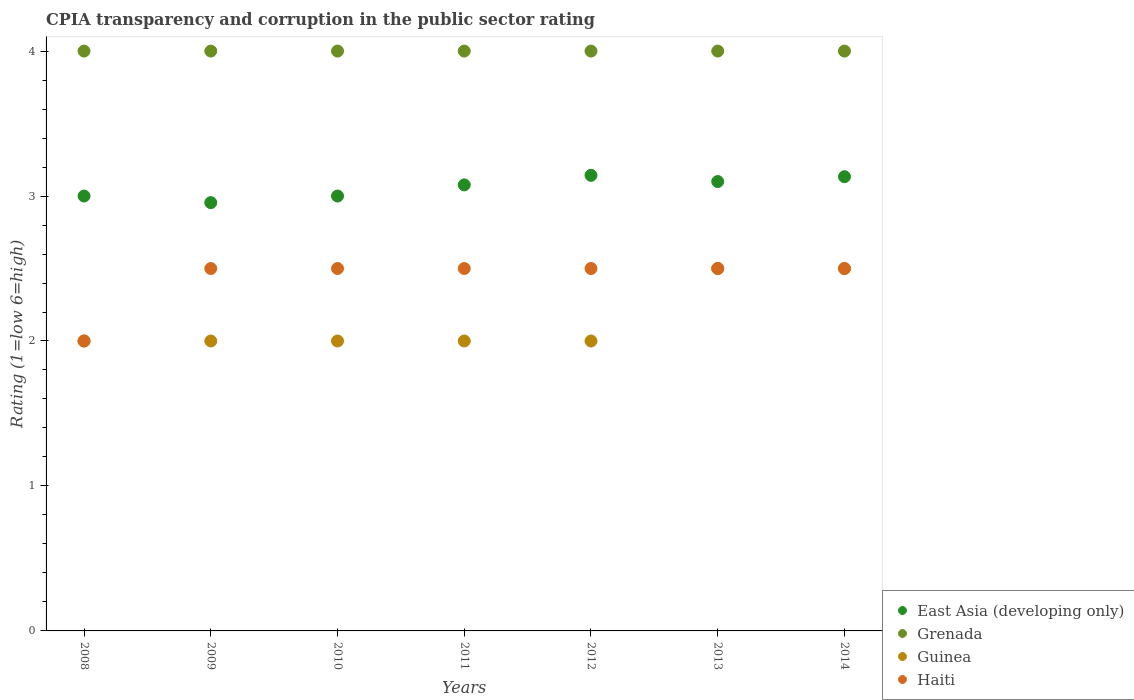Is the number of dotlines equal to the number of legend labels?
Your answer should be compact. Yes. What is the CPIA rating in East Asia (developing only) in 2010?
Your answer should be compact. 3. Across all years, what is the minimum CPIA rating in Grenada?
Provide a succinct answer. 4. In which year was the CPIA rating in Haiti minimum?
Your answer should be compact. 2008. What is the total CPIA rating in Grenada in the graph?
Make the answer very short. 28. What is the difference between the CPIA rating in Haiti in 2010 and that in 2012?
Make the answer very short. 0. What is the average CPIA rating in Haiti per year?
Offer a very short reply. 2.43. What is the ratio of the CPIA rating in Haiti in 2010 to that in 2011?
Ensure brevity in your answer.  1. Is it the case that in every year, the sum of the CPIA rating in East Asia (developing only) and CPIA rating in Haiti  is greater than the CPIA rating in Grenada?
Offer a very short reply. Yes. Is the CPIA rating in Guinea strictly greater than the CPIA rating in Grenada over the years?
Your response must be concise. No. How many years are there in the graph?
Give a very brief answer. 7. Are the values on the major ticks of Y-axis written in scientific E-notation?
Offer a very short reply. No. How many legend labels are there?
Make the answer very short. 4. What is the title of the graph?
Your answer should be compact. CPIA transparency and corruption in the public sector rating. What is the label or title of the X-axis?
Ensure brevity in your answer.  Years. What is the Rating (1=low 6=high) in Grenada in 2008?
Your answer should be very brief. 4. What is the Rating (1=low 6=high) in East Asia (developing only) in 2009?
Offer a terse response. 2.95. What is the Rating (1=low 6=high) of Guinea in 2009?
Make the answer very short. 2. What is the Rating (1=low 6=high) in Grenada in 2010?
Offer a terse response. 4. What is the Rating (1=low 6=high) of Guinea in 2010?
Give a very brief answer. 2. What is the Rating (1=low 6=high) in East Asia (developing only) in 2011?
Your answer should be very brief. 3.08. What is the Rating (1=low 6=high) of Grenada in 2011?
Offer a terse response. 4. What is the Rating (1=low 6=high) of Guinea in 2011?
Offer a terse response. 2. What is the Rating (1=low 6=high) in East Asia (developing only) in 2012?
Your answer should be very brief. 3.14. What is the Rating (1=low 6=high) of Guinea in 2012?
Offer a terse response. 2. What is the Rating (1=low 6=high) of Haiti in 2012?
Offer a terse response. 2.5. What is the Rating (1=low 6=high) in Haiti in 2013?
Make the answer very short. 2.5. What is the Rating (1=low 6=high) of East Asia (developing only) in 2014?
Make the answer very short. 3.13. What is the Rating (1=low 6=high) of Grenada in 2014?
Provide a short and direct response. 4. What is the Rating (1=low 6=high) in Guinea in 2014?
Make the answer very short. 2.5. Across all years, what is the maximum Rating (1=low 6=high) in East Asia (developing only)?
Offer a very short reply. 3.14. Across all years, what is the maximum Rating (1=low 6=high) in Guinea?
Your answer should be compact. 2.5. Across all years, what is the maximum Rating (1=low 6=high) in Haiti?
Your answer should be very brief. 2.5. Across all years, what is the minimum Rating (1=low 6=high) in East Asia (developing only)?
Your answer should be very brief. 2.95. Across all years, what is the minimum Rating (1=low 6=high) of Grenada?
Provide a succinct answer. 4. Across all years, what is the minimum Rating (1=low 6=high) of Haiti?
Your response must be concise. 2. What is the total Rating (1=low 6=high) of East Asia (developing only) in the graph?
Provide a succinct answer. 21.41. What is the difference between the Rating (1=low 6=high) of East Asia (developing only) in 2008 and that in 2009?
Your answer should be compact. 0.05. What is the difference between the Rating (1=low 6=high) in Grenada in 2008 and that in 2009?
Your response must be concise. 0. What is the difference between the Rating (1=low 6=high) of Guinea in 2008 and that in 2009?
Keep it short and to the point. 0. What is the difference between the Rating (1=low 6=high) in East Asia (developing only) in 2008 and that in 2011?
Make the answer very short. -0.08. What is the difference between the Rating (1=low 6=high) in Haiti in 2008 and that in 2011?
Provide a succinct answer. -0.5. What is the difference between the Rating (1=low 6=high) in East Asia (developing only) in 2008 and that in 2012?
Your answer should be very brief. -0.14. What is the difference between the Rating (1=low 6=high) in Haiti in 2008 and that in 2012?
Provide a short and direct response. -0.5. What is the difference between the Rating (1=low 6=high) of East Asia (developing only) in 2008 and that in 2013?
Your response must be concise. -0.1. What is the difference between the Rating (1=low 6=high) in Grenada in 2008 and that in 2013?
Provide a succinct answer. 0. What is the difference between the Rating (1=low 6=high) in East Asia (developing only) in 2008 and that in 2014?
Provide a short and direct response. -0.13. What is the difference between the Rating (1=low 6=high) in Guinea in 2008 and that in 2014?
Keep it short and to the point. -0.5. What is the difference between the Rating (1=low 6=high) in Haiti in 2008 and that in 2014?
Make the answer very short. -0.5. What is the difference between the Rating (1=low 6=high) in East Asia (developing only) in 2009 and that in 2010?
Make the answer very short. -0.05. What is the difference between the Rating (1=low 6=high) of Haiti in 2009 and that in 2010?
Ensure brevity in your answer.  0. What is the difference between the Rating (1=low 6=high) of East Asia (developing only) in 2009 and that in 2011?
Your response must be concise. -0.12. What is the difference between the Rating (1=low 6=high) in Guinea in 2009 and that in 2011?
Offer a terse response. 0. What is the difference between the Rating (1=low 6=high) in Haiti in 2009 and that in 2011?
Ensure brevity in your answer.  0. What is the difference between the Rating (1=low 6=high) of East Asia (developing only) in 2009 and that in 2012?
Make the answer very short. -0.19. What is the difference between the Rating (1=low 6=high) of Grenada in 2009 and that in 2012?
Give a very brief answer. 0. What is the difference between the Rating (1=low 6=high) in Haiti in 2009 and that in 2012?
Your answer should be compact. 0. What is the difference between the Rating (1=low 6=high) of East Asia (developing only) in 2009 and that in 2013?
Keep it short and to the point. -0.15. What is the difference between the Rating (1=low 6=high) in Grenada in 2009 and that in 2013?
Your response must be concise. 0. What is the difference between the Rating (1=low 6=high) of Guinea in 2009 and that in 2013?
Make the answer very short. -0.5. What is the difference between the Rating (1=low 6=high) in East Asia (developing only) in 2009 and that in 2014?
Offer a very short reply. -0.18. What is the difference between the Rating (1=low 6=high) in Grenada in 2009 and that in 2014?
Make the answer very short. 0. What is the difference between the Rating (1=low 6=high) in Guinea in 2009 and that in 2014?
Your response must be concise. -0.5. What is the difference between the Rating (1=low 6=high) in East Asia (developing only) in 2010 and that in 2011?
Ensure brevity in your answer.  -0.08. What is the difference between the Rating (1=low 6=high) in Grenada in 2010 and that in 2011?
Your answer should be very brief. 0. What is the difference between the Rating (1=low 6=high) in Haiti in 2010 and that in 2011?
Provide a succinct answer. 0. What is the difference between the Rating (1=low 6=high) of East Asia (developing only) in 2010 and that in 2012?
Offer a terse response. -0.14. What is the difference between the Rating (1=low 6=high) of Haiti in 2010 and that in 2012?
Provide a succinct answer. 0. What is the difference between the Rating (1=low 6=high) in Guinea in 2010 and that in 2013?
Provide a succinct answer. -0.5. What is the difference between the Rating (1=low 6=high) in Haiti in 2010 and that in 2013?
Your response must be concise. 0. What is the difference between the Rating (1=low 6=high) in East Asia (developing only) in 2010 and that in 2014?
Ensure brevity in your answer.  -0.13. What is the difference between the Rating (1=low 6=high) of Haiti in 2010 and that in 2014?
Your answer should be compact. 0. What is the difference between the Rating (1=low 6=high) in East Asia (developing only) in 2011 and that in 2012?
Ensure brevity in your answer.  -0.07. What is the difference between the Rating (1=low 6=high) of Guinea in 2011 and that in 2012?
Give a very brief answer. 0. What is the difference between the Rating (1=low 6=high) in East Asia (developing only) in 2011 and that in 2013?
Your response must be concise. -0.02. What is the difference between the Rating (1=low 6=high) in Grenada in 2011 and that in 2013?
Your answer should be very brief. 0. What is the difference between the Rating (1=low 6=high) in Haiti in 2011 and that in 2013?
Ensure brevity in your answer.  0. What is the difference between the Rating (1=low 6=high) in East Asia (developing only) in 2011 and that in 2014?
Offer a terse response. -0.06. What is the difference between the Rating (1=low 6=high) in Guinea in 2011 and that in 2014?
Give a very brief answer. -0.5. What is the difference between the Rating (1=low 6=high) in East Asia (developing only) in 2012 and that in 2013?
Your answer should be compact. 0.04. What is the difference between the Rating (1=low 6=high) in Grenada in 2012 and that in 2013?
Your answer should be compact. 0. What is the difference between the Rating (1=low 6=high) in East Asia (developing only) in 2012 and that in 2014?
Offer a very short reply. 0.01. What is the difference between the Rating (1=low 6=high) of Grenada in 2012 and that in 2014?
Offer a terse response. 0. What is the difference between the Rating (1=low 6=high) in East Asia (developing only) in 2013 and that in 2014?
Give a very brief answer. -0.03. What is the difference between the Rating (1=low 6=high) of East Asia (developing only) in 2008 and the Rating (1=low 6=high) of Haiti in 2009?
Provide a succinct answer. 0.5. What is the difference between the Rating (1=low 6=high) in Grenada in 2008 and the Rating (1=low 6=high) in Haiti in 2009?
Offer a very short reply. 1.5. What is the difference between the Rating (1=low 6=high) of Guinea in 2008 and the Rating (1=low 6=high) of Haiti in 2009?
Make the answer very short. -0.5. What is the difference between the Rating (1=low 6=high) in East Asia (developing only) in 2008 and the Rating (1=low 6=high) in Haiti in 2010?
Your response must be concise. 0.5. What is the difference between the Rating (1=low 6=high) of Grenada in 2008 and the Rating (1=low 6=high) of Guinea in 2010?
Make the answer very short. 2. What is the difference between the Rating (1=low 6=high) in Grenada in 2008 and the Rating (1=low 6=high) in Haiti in 2010?
Ensure brevity in your answer.  1.5. What is the difference between the Rating (1=low 6=high) in Grenada in 2008 and the Rating (1=low 6=high) in Guinea in 2011?
Make the answer very short. 2. What is the difference between the Rating (1=low 6=high) of Guinea in 2008 and the Rating (1=low 6=high) of Haiti in 2011?
Your answer should be compact. -0.5. What is the difference between the Rating (1=low 6=high) of Guinea in 2008 and the Rating (1=low 6=high) of Haiti in 2012?
Offer a very short reply. -0.5. What is the difference between the Rating (1=low 6=high) of East Asia (developing only) in 2008 and the Rating (1=low 6=high) of Grenada in 2013?
Give a very brief answer. -1. What is the difference between the Rating (1=low 6=high) in East Asia (developing only) in 2008 and the Rating (1=low 6=high) in Guinea in 2013?
Provide a succinct answer. 0.5. What is the difference between the Rating (1=low 6=high) of Guinea in 2008 and the Rating (1=low 6=high) of Haiti in 2013?
Provide a short and direct response. -0.5. What is the difference between the Rating (1=low 6=high) of East Asia (developing only) in 2008 and the Rating (1=low 6=high) of Grenada in 2014?
Your answer should be compact. -1. What is the difference between the Rating (1=low 6=high) of East Asia (developing only) in 2008 and the Rating (1=low 6=high) of Guinea in 2014?
Offer a terse response. 0.5. What is the difference between the Rating (1=low 6=high) of East Asia (developing only) in 2008 and the Rating (1=low 6=high) of Haiti in 2014?
Give a very brief answer. 0.5. What is the difference between the Rating (1=low 6=high) of East Asia (developing only) in 2009 and the Rating (1=low 6=high) of Grenada in 2010?
Your response must be concise. -1.05. What is the difference between the Rating (1=low 6=high) of East Asia (developing only) in 2009 and the Rating (1=low 6=high) of Guinea in 2010?
Keep it short and to the point. 0.95. What is the difference between the Rating (1=low 6=high) in East Asia (developing only) in 2009 and the Rating (1=low 6=high) in Haiti in 2010?
Your answer should be very brief. 0.45. What is the difference between the Rating (1=low 6=high) of Grenada in 2009 and the Rating (1=low 6=high) of Guinea in 2010?
Give a very brief answer. 2. What is the difference between the Rating (1=low 6=high) in Grenada in 2009 and the Rating (1=low 6=high) in Haiti in 2010?
Keep it short and to the point. 1.5. What is the difference between the Rating (1=low 6=high) in Guinea in 2009 and the Rating (1=low 6=high) in Haiti in 2010?
Offer a terse response. -0.5. What is the difference between the Rating (1=low 6=high) in East Asia (developing only) in 2009 and the Rating (1=low 6=high) in Grenada in 2011?
Provide a short and direct response. -1.05. What is the difference between the Rating (1=low 6=high) of East Asia (developing only) in 2009 and the Rating (1=low 6=high) of Guinea in 2011?
Provide a succinct answer. 0.95. What is the difference between the Rating (1=low 6=high) in East Asia (developing only) in 2009 and the Rating (1=low 6=high) in Haiti in 2011?
Your answer should be compact. 0.45. What is the difference between the Rating (1=low 6=high) of Guinea in 2009 and the Rating (1=low 6=high) of Haiti in 2011?
Give a very brief answer. -0.5. What is the difference between the Rating (1=low 6=high) in East Asia (developing only) in 2009 and the Rating (1=low 6=high) in Grenada in 2012?
Make the answer very short. -1.05. What is the difference between the Rating (1=low 6=high) in East Asia (developing only) in 2009 and the Rating (1=low 6=high) in Guinea in 2012?
Your response must be concise. 0.95. What is the difference between the Rating (1=low 6=high) in East Asia (developing only) in 2009 and the Rating (1=low 6=high) in Haiti in 2012?
Your answer should be compact. 0.45. What is the difference between the Rating (1=low 6=high) in Grenada in 2009 and the Rating (1=low 6=high) in Guinea in 2012?
Offer a very short reply. 2. What is the difference between the Rating (1=low 6=high) of Grenada in 2009 and the Rating (1=low 6=high) of Haiti in 2012?
Offer a terse response. 1.5. What is the difference between the Rating (1=low 6=high) of Guinea in 2009 and the Rating (1=low 6=high) of Haiti in 2012?
Your answer should be very brief. -0.5. What is the difference between the Rating (1=low 6=high) in East Asia (developing only) in 2009 and the Rating (1=low 6=high) in Grenada in 2013?
Keep it short and to the point. -1.05. What is the difference between the Rating (1=low 6=high) of East Asia (developing only) in 2009 and the Rating (1=low 6=high) of Guinea in 2013?
Provide a short and direct response. 0.45. What is the difference between the Rating (1=low 6=high) in East Asia (developing only) in 2009 and the Rating (1=low 6=high) in Haiti in 2013?
Ensure brevity in your answer.  0.45. What is the difference between the Rating (1=low 6=high) of Grenada in 2009 and the Rating (1=low 6=high) of Haiti in 2013?
Provide a short and direct response. 1.5. What is the difference between the Rating (1=low 6=high) of Guinea in 2009 and the Rating (1=low 6=high) of Haiti in 2013?
Keep it short and to the point. -0.5. What is the difference between the Rating (1=low 6=high) of East Asia (developing only) in 2009 and the Rating (1=low 6=high) of Grenada in 2014?
Ensure brevity in your answer.  -1.05. What is the difference between the Rating (1=low 6=high) of East Asia (developing only) in 2009 and the Rating (1=low 6=high) of Guinea in 2014?
Your answer should be very brief. 0.45. What is the difference between the Rating (1=low 6=high) of East Asia (developing only) in 2009 and the Rating (1=low 6=high) of Haiti in 2014?
Your answer should be compact. 0.45. What is the difference between the Rating (1=low 6=high) of Grenada in 2009 and the Rating (1=low 6=high) of Guinea in 2014?
Make the answer very short. 1.5. What is the difference between the Rating (1=low 6=high) in Guinea in 2009 and the Rating (1=low 6=high) in Haiti in 2014?
Offer a terse response. -0.5. What is the difference between the Rating (1=low 6=high) in East Asia (developing only) in 2010 and the Rating (1=low 6=high) in Guinea in 2011?
Your answer should be very brief. 1. What is the difference between the Rating (1=low 6=high) in Grenada in 2010 and the Rating (1=low 6=high) in Guinea in 2011?
Offer a terse response. 2. What is the difference between the Rating (1=low 6=high) in East Asia (developing only) in 2010 and the Rating (1=low 6=high) in Guinea in 2012?
Give a very brief answer. 1. What is the difference between the Rating (1=low 6=high) of Grenada in 2010 and the Rating (1=low 6=high) of Haiti in 2012?
Your answer should be compact. 1.5. What is the difference between the Rating (1=low 6=high) of East Asia (developing only) in 2010 and the Rating (1=low 6=high) of Grenada in 2013?
Provide a short and direct response. -1. What is the difference between the Rating (1=low 6=high) in Grenada in 2010 and the Rating (1=low 6=high) in Guinea in 2013?
Your response must be concise. 1.5. What is the difference between the Rating (1=low 6=high) of Grenada in 2010 and the Rating (1=low 6=high) of Haiti in 2013?
Provide a short and direct response. 1.5. What is the difference between the Rating (1=low 6=high) in Guinea in 2010 and the Rating (1=low 6=high) in Haiti in 2013?
Provide a succinct answer. -0.5. What is the difference between the Rating (1=low 6=high) in East Asia (developing only) in 2010 and the Rating (1=low 6=high) in Grenada in 2014?
Your answer should be compact. -1. What is the difference between the Rating (1=low 6=high) of East Asia (developing only) in 2010 and the Rating (1=low 6=high) of Haiti in 2014?
Keep it short and to the point. 0.5. What is the difference between the Rating (1=low 6=high) of Guinea in 2010 and the Rating (1=low 6=high) of Haiti in 2014?
Provide a succinct answer. -0.5. What is the difference between the Rating (1=low 6=high) in East Asia (developing only) in 2011 and the Rating (1=low 6=high) in Grenada in 2012?
Ensure brevity in your answer.  -0.92. What is the difference between the Rating (1=low 6=high) in East Asia (developing only) in 2011 and the Rating (1=low 6=high) in Haiti in 2012?
Your response must be concise. 0.58. What is the difference between the Rating (1=low 6=high) in Guinea in 2011 and the Rating (1=low 6=high) in Haiti in 2012?
Offer a very short reply. -0.5. What is the difference between the Rating (1=low 6=high) of East Asia (developing only) in 2011 and the Rating (1=low 6=high) of Grenada in 2013?
Your answer should be compact. -0.92. What is the difference between the Rating (1=low 6=high) of East Asia (developing only) in 2011 and the Rating (1=low 6=high) of Guinea in 2013?
Your response must be concise. 0.58. What is the difference between the Rating (1=low 6=high) of East Asia (developing only) in 2011 and the Rating (1=low 6=high) of Haiti in 2013?
Offer a terse response. 0.58. What is the difference between the Rating (1=low 6=high) in Grenada in 2011 and the Rating (1=low 6=high) in Guinea in 2013?
Your answer should be compact. 1.5. What is the difference between the Rating (1=low 6=high) in East Asia (developing only) in 2011 and the Rating (1=low 6=high) in Grenada in 2014?
Provide a succinct answer. -0.92. What is the difference between the Rating (1=low 6=high) of East Asia (developing only) in 2011 and the Rating (1=low 6=high) of Guinea in 2014?
Your response must be concise. 0.58. What is the difference between the Rating (1=low 6=high) of East Asia (developing only) in 2011 and the Rating (1=low 6=high) of Haiti in 2014?
Give a very brief answer. 0.58. What is the difference between the Rating (1=low 6=high) of Grenada in 2011 and the Rating (1=low 6=high) of Haiti in 2014?
Give a very brief answer. 1.5. What is the difference between the Rating (1=low 6=high) in Guinea in 2011 and the Rating (1=low 6=high) in Haiti in 2014?
Provide a succinct answer. -0.5. What is the difference between the Rating (1=low 6=high) in East Asia (developing only) in 2012 and the Rating (1=low 6=high) in Grenada in 2013?
Your response must be concise. -0.86. What is the difference between the Rating (1=low 6=high) in East Asia (developing only) in 2012 and the Rating (1=low 6=high) in Guinea in 2013?
Keep it short and to the point. 0.64. What is the difference between the Rating (1=low 6=high) of East Asia (developing only) in 2012 and the Rating (1=low 6=high) of Haiti in 2013?
Give a very brief answer. 0.64. What is the difference between the Rating (1=low 6=high) in Grenada in 2012 and the Rating (1=low 6=high) in Guinea in 2013?
Keep it short and to the point. 1.5. What is the difference between the Rating (1=low 6=high) of Grenada in 2012 and the Rating (1=low 6=high) of Haiti in 2013?
Offer a very short reply. 1.5. What is the difference between the Rating (1=low 6=high) in Guinea in 2012 and the Rating (1=low 6=high) in Haiti in 2013?
Your answer should be very brief. -0.5. What is the difference between the Rating (1=low 6=high) in East Asia (developing only) in 2012 and the Rating (1=low 6=high) in Grenada in 2014?
Ensure brevity in your answer.  -0.86. What is the difference between the Rating (1=low 6=high) in East Asia (developing only) in 2012 and the Rating (1=low 6=high) in Guinea in 2014?
Provide a short and direct response. 0.64. What is the difference between the Rating (1=low 6=high) of East Asia (developing only) in 2012 and the Rating (1=low 6=high) of Haiti in 2014?
Make the answer very short. 0.64. What is the difference between the Rating (1=low 6=high) in Guinea in 2012 and the Rating (1=low 6=high) in Haiti in 2014?
Your answer should be very brief. -0.5. What is the difference between the Rating (1=low 6=high) of East Asia (developing only) in 2013 and the Rating (1=low 6=high) of Grenada in 2014?
Provide a short and direct response. -0.9. What is the difference between the Rating (1=low 6=high) in Guinea in 2013 and the Rating (1=low 6=high) in Haiti in 2014?
Your answer should be compact. 0. What is the average Rating (1=low 6=high) of East Asia (developing only) per year?
Keep it short and to the point. 3.06. What is the average Rating (1=low 6=high) in Guinea per year?
Keep it short and to the point. 2.14. What is the average Rating (1=low 6=high) in Haiti per year?
Ensure brevity in your answer.  2.43. In the year 2008, what is the difference between the Rating (1=low 6=high) in East Asia (developing only) and Rating (1=low 6=high) in Grenada?
Ensure brevity in your answer.  -1. In the year 2008, what is the difference between the Rating (1=low 6=high) in East Asia (developing only) and Rating (1=low 6=high) in Guinea?
Provide a succinct answer. 1. In the year 2008, what is the difference between the Rating (1=low 6=high) of East Asia (developing only) and Rating (1=low 6=high) of Haiti?
Offer a terse response. 1. In the year 2008, what is the difference between the Rating (1=low 6=high) of Grenada and Rating (1=low 6=high) of Guinea?
Ensure brevity in your answer.  2. In the year 2008, what is the difference between the Rating (1=low 6=high) in Guinea and Rating (1=low 6=high) in Haiti?
Make the answer very short. 0. In the year 2009, what is the difference between the Rating (1=low 6=high) of East Asia (developing only) and Rating (1=low 6=high) of Grenada?
Offer a very short reply. -1.05. In the year 2009, what is the difference between the Rating (1=low 6=high) of East Asia (developing only) and Rating (1=low 6=high) of Guinea?
Provide a succinct answer. 0.95. In the year 2009, what is the difference between the Rating (1=low 6=high) in East Asia (developing only) and Rating (1=low 6=high) in Haiti?
Give a very brief answer. 0.45. In the year 2009, what is the difference between the Rating (1=low 6=high) in Grenada and Rating (1=low 6=high) in Haiti?
Your answer should be compact. 1.5. In the year 2010, what is the difference between the Rating (1=low 6=high) in East Asia (developing only) and Rating (1=low 6=high) in Grenada?
Provide a succinct answer. -1. In the year 2010, what is the difference between the Rating (1=low 6=high) of East Asia (developing only) and Rating (1=low 6=high) of Guinea?
Give a very brief answer. 1. In the year 2010, what is the difference between the Rating (1=low 6=high) of Grenada and Rating (1=low 6=high) of Haiti?
Provide a succinct answer. 1.5. In the year 2010, what is the difference between the Rating (1=low 6=high) of Guinea and Rating (1=low 6=high) of Haiti?
Provide a succinct answer. -0.5. In the year 2011, what is the difference between the Rating (1=low 6=high) of East Asia (developing only) and Rating (1=low 6=high) of Grenada?
Offer a terse response. -0.92. In the year 2011, what is the difference between the Rating (1=low 6=high) of East Asia (developing only) and Rating (1=low 6=high) of Guinea?
Give a very brief answer. 1.08. In the year 2011, what is the difference between the Rating (1=low 6=high) in East Asia (developing only) and Rating (1=low 6=high) in Haiti?
Your answer should be compact. 0.58. In the year 2011, what is the difference between the Rating (1=low 6=high) in Guinea and Rating (1=low 6=high) in Haiti?
Ensure brevity in your answer.  -0.5. In the year 2012, what is the difference between the Rating (1=low 6=high) of East Asia (developing only) and Rating (1=low 6=high) of Grenada?
Make the answer very short. -0.86. In the year 2012, what is the difference between the Rating (1=low 6=high) in East Asia (developing only) and Rating (1=low 6=high) in Haiti?
Give a very brief answer. 0.64. In the year 2012, what is the difference between the Rating (1=low 6=high) in Grenada and Rating (1=low 6=high) in Haiti?
Give a very brief answer. 1.5. In the year 2012, what is the difference between the Rating (1=low 6=high) of Guinea and Rating (1=low 6=high) of Haiti?
Your response must be concise. -0.5. In the year 2013, what is the difference between the Rating (1=low 6=high) of East Asia (developing only) and Rating (1=low 6=high) of Guinea?
Give a very brief answer. 0.6. In the year 2013, what is the difference between the Rating (1=low 6=high) of East Asia (developing only) and Rating (1=low 6=high) of Haiti?
Provide a succinct answer. 0.6. In the year 2013, what is the difference between the Rating (1=low 6=high) in Grenada and Rating (1=low 6=high) in Haiti?
Offer a terse response. 1.5. In the year 2014, what is the difference between the Rating (1=low 6=high) in East Asia (developing only) and Rating (1=low 6=high) in Grenada?
Offer a terse response. -0.87. In the year 2014, what is the difference between the Rating (1=low 6=high) in East Asia (developing only) and Rating (1=low 6=high) in Guinea?
Your answer should be very brief. 0.63. In the year 2014, what is the difference between the Rating (1=low 6=high) in East Asia (developing only) and Rating (1=low 6=high) in Haiti?
Provide a short and direct response. 0.63. In the year 2014, what is the difference between the Rating (1=low 6=high) in Grenada and Rating (1=low 6=high) in Guinea?
Ensure brevity in your answer.  1.5. In the year 2014, what is the difference between the Rating (1=low 6=high) of Grenada and Rating (1=low 6=high) of Haiti?
Your answer should be compact. 1.5. What is the ratio of the Rating (1=low 6=high) in East Asia (developing only) in 2008 to that in 2009?
Offer a very short reply. 1.02. What is the ratio of the Rating (1=low 6=high) of Guinea in 2008 to that in 2009?
Your response must be concise. 1. What is the ratio of the Rating (1=low 6=high) of Grenada in 2008 to that in 2010?
Offer a terse response. 1. What is the ratio of the Rating (1=low 6=high) in Haiti in 2008 to that in 2011?
Your answer should be compact. 0.8. What is the ratio of the Rating (1=low 6=high) in East Asia (developing only) in 2008 to that in 2012?
Provide a short and direct response. 0.95. What is the ratio of the Rating (1=low 6=high) of Grenada in 2008 to that in 2012?
Give a very brief answer. 1. What is the ratio of the Rating (1=low 6=high) in Guinea in 2008 to that in 2012?
Offer a very short reply. 1. What is the ratio of the Rating (1=low 6=high) of Haiti in 2008 to that in 2012?
Make the answer very short. 0.8. What is the ratio of the Rating (1=low 6=high) in East Asia (developing only) in 2008 to that in 2013?
Your response must be concise. 0.97. What is the ratio of the Rating (1=low 6=high) in Grenada in 2008 to that in 2013?
Make the answer very short. 1. What is the ratio of the Rating (1=low 6=high) of East Asia (developing only) in 2008 to that in 2014?
Your answer should be compact. 0.96. What is the ratio of the Rating (1=low 6=high) of Grenada in 2008 to that in 2014?
Offer a very short reply. 1. What is the ratio of the Rating (1=low 6=high) of East Asia (developing only) in 2009 to that in 2010?
Your answer should be compact. 0.98. What is the ratio of the Rating (1=low 6=high) of Grenada in 2009 to that in 2010?
Ensure brevity in your answer.  1. What is the ratio of the Rating (1=low 6=high) of Guinea in 2009 to that in 2010?
Your response must be concise. 1. What is the ratio of the Rating (1=low 6=high) of East Asia (developing only) in 2009 to that in 2011?
Your response must be concise. 0.96. What is the ratio of the Rating (1=low 6=high) in Grenada in 2009 to that in 2011?
Your answer should be compact. 1. What is the ratio of the Rating (1=low 6=high) of East Asia (developing only) in 2009 to that in 2012?
Give a very brief answer. 0.94. What is the ratio of the Rating (1=low 6=high) of Guinea in 2009 to that in 2012?
Your answer should be compact. 1. What is the ratio of the Rating (1=low 6=high) in Haiti in 2009 to that in 2012?
Your answer should be compact. 1. What is the ratio of the Rating (1=low 6=high) in East Asia (developing only) in 2009 to that in 2013?
Offer a very short reply. 0.95. What is the ratio of the Rating (1=low 6=high) of Grenada in 2009 to that in 2013?
Keep it short and to the point. 1. What is the ratio of the Rating (1=low 6=high) in Haiti in 2009 to that in 2013?
Offer a very short reply. 1. What is the ratio of the Rating (1=low 6=high) of East Asia (developing only) in 2009 to that in 2014?
Keep it short and to the point. 0.94. What is the ratio of the Rating (1=low 6=high) in Grenada in 2009 to that in 2014?
Your answer should be compact. 1. What is the ratio of the Rating (1=low 6=high) of Haiti in 2009 to that in 2014?
Keep it short and to the point. 1. What is the ratio of the Rating (1=low 6=high) in Guinea in 2010 to that in 2011?
Provide a succinct answer. 1. What is the ratio of the Rating (1=low 6=high) in East Asia (developing only) in 2010 to that in 2012?
Provide a short and direct response. 0.95. What is the ratio of the Rating (1=low 6=high) of Guinea in 2010 to that in 2013?
Your answer should be very brief. 0.8. What is the ratio of the Rating (1=low 6=high) of East Asia (developing only) in 2010 to that in 2014?
Your answer should be compact. 0.96. What is the ratio of the Rating (1=low 6=high) in Grenada in 2010 to that in 2014?
Provide a succinct answer. 1. What is the ratio of the Rating (1=low 6=high) in Guinea in 2011 to that in 2012?
Give a very brief answer. 1. What is the ratio of the Rating (1=low 6=high) in Grenada in 2011 to that in 2013?
Your answer should be compact. 1. What is the ratio of the Rating (1=low 6=high) in Guinea in 2011 to that in 2013?
Give a very brief answer. 0.8. What is the ratio of the Rating (1=low 6=high) in Haiti in 2011 to that in 2013?
Keep it short and to the point. 1. What is the ratio of the Rating (1=low 6=high) of East Asia (developing only) in 2011 to that in 2014?
Provide a short and direct response. 0.98. What is the ratio of the Rating (1=low 6=high) of Guinea in 2011 to that in 2014?
Provide a short and direct response. 0.8. What is the ratio of the Rating (1=low 6=high) of East Asia (developing only) in 2012 to that in 2013?
Provide a short and direct response. 1.01. What is the ratio of the Rating (1=low 6=high) of Haiti in 2012 to that in 2013?
Your answer should be compact. 1. What is the ratio of the Rating (1=low 6=high) of Haiti in 2012 to that in 2014?
Offer a very short reply. 1. What is the ratio of the Rating (1=low 6=high) in Grenada in 2013 to that in 2014?
Provide a short and direct response. 1. What is the ratio of the Rating (1=low 6=high) in Guinea in 2013 to that in 2014?
Your response must be concise. 1. What is the ratio of the Rating (1=low 6=high) of Haiti in 2013 to that in 2014?
Make the answer very short. 1. What is the difference between the highest and the second highest Rating (1=low 6=high) in East Asia (developing only)?
Provide a succinct answer. 0.01. What is the difference between the highest and the second highest Rating (1=low 6=high) in Haiti?
Offer a very short reply. 0. What is the difference between the highest and the lowest Rating (1=low 6=high) of East Asia (developing only)?
Ensure brevity in your answer.  0.19. What is the difference between the highest and the lowest Rating (1=low 6=high) of Guinea?
Ensure brevity in your answer.  0.5. 